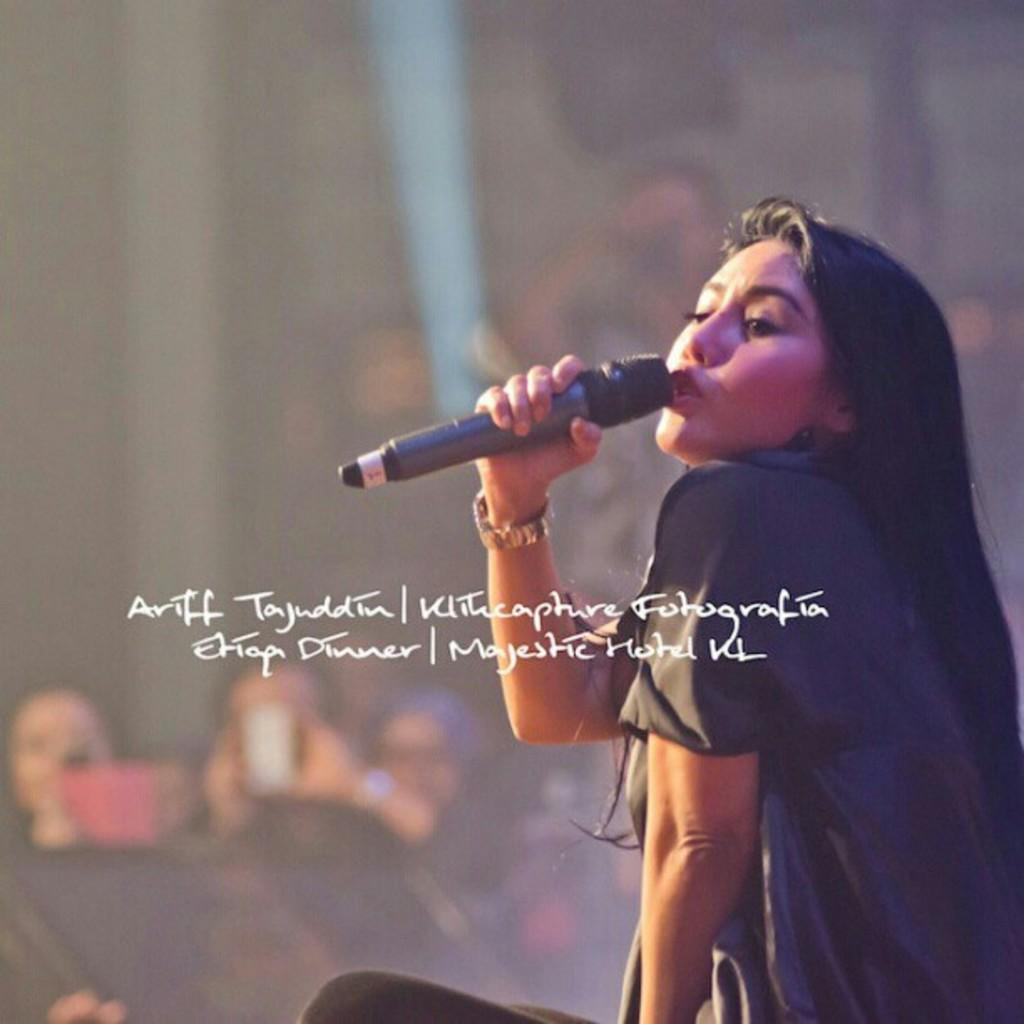What is the person in the image holding? The person in the image is holding a microphone. What activity is the person engaged in? The person is singing a song. What can be observed about the person's mouth? The person's mouth is open. Can you describe the background of the image? There is a group of people in the background of the image. Is the farmer in the image holding a bear while singing? There is no farmer or bear present in the image; it features a person holding a microphone and singing. 